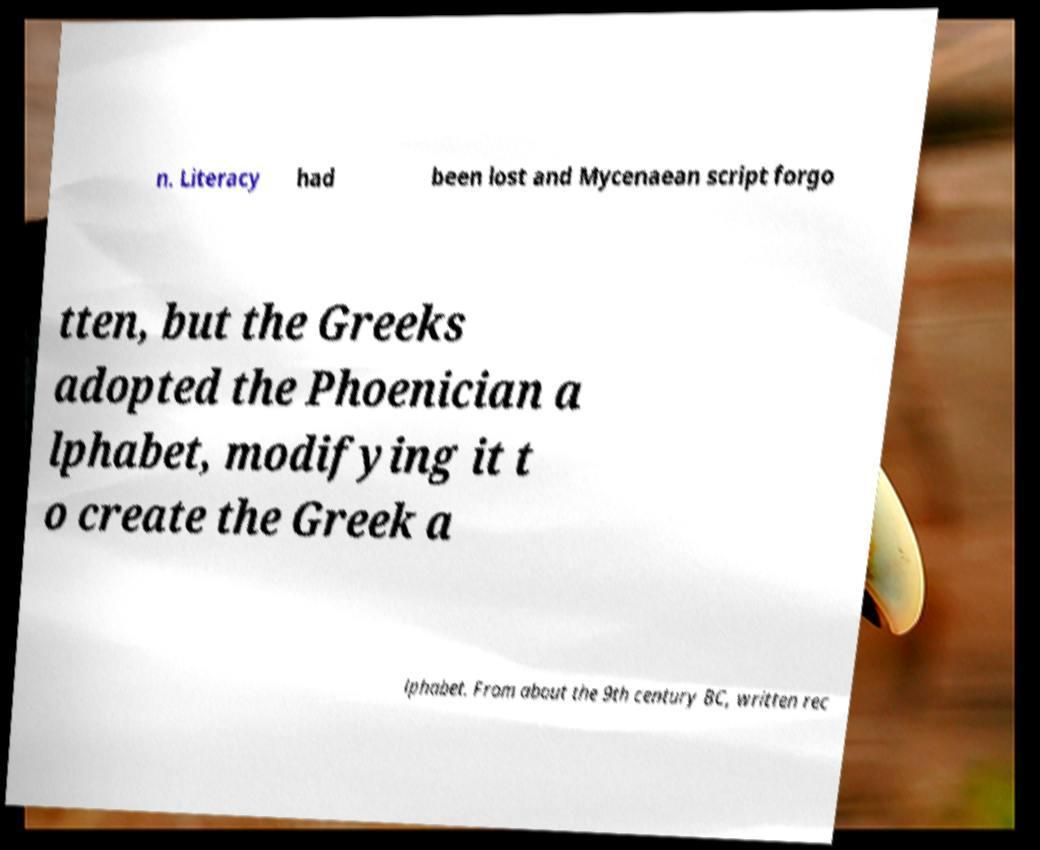I need the written content from this picture converted into text. Can you do that? n. Literacy had been lost and Mycenaean script forgo tten, but the Greeks adopted the Phoenician a lphabet, modifying it t o create the Greek a lphabet. From about the 9th century BC, written rec 